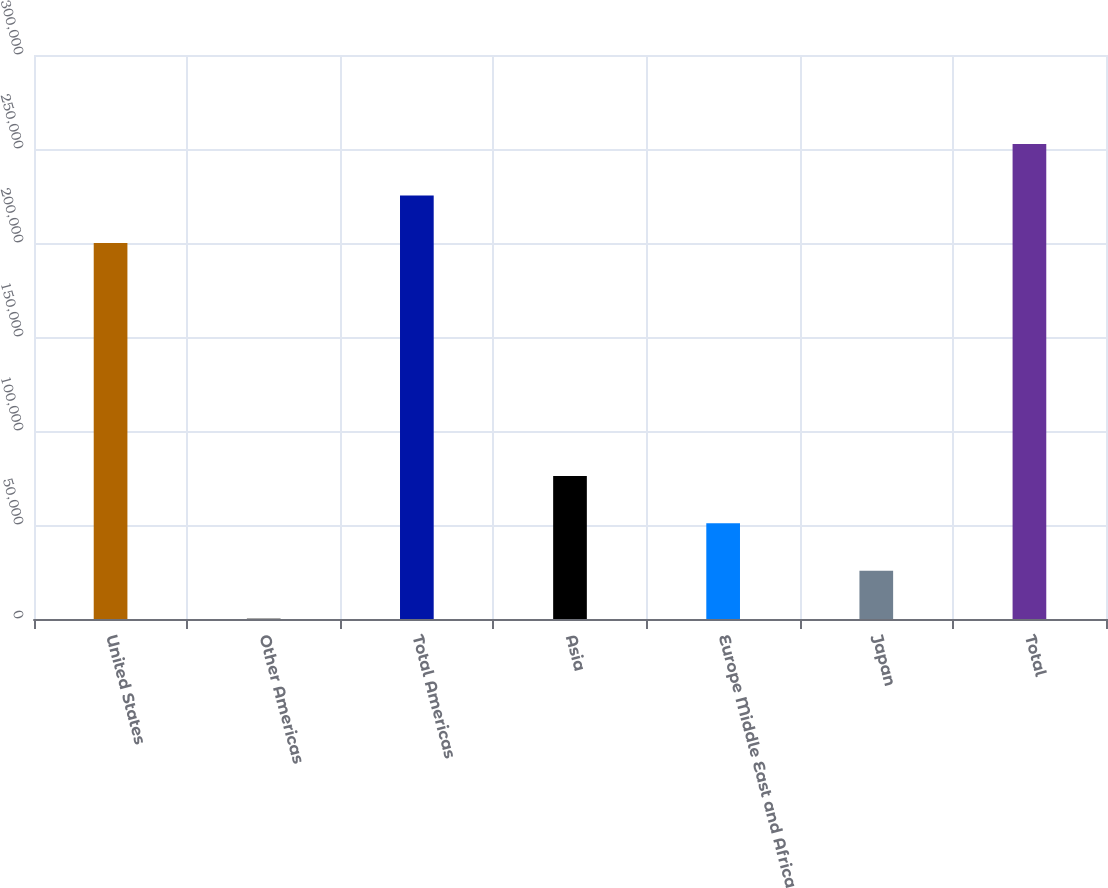Convert chart. <chart><loc_0><loc_0><loc_500><loc_500><bar_chart><fcel>United States<fcel>Other Americas<fcel>Total Americas<fcel>Asia<fcel>Europe Middle East and Africa<fcel>Japan<fcel>Total<nl><fcel>200025<fcel>475<fcel>225240<fcel>76121.5<fcel>50906<fcel>25690.5<fcel>252630<nl></chart> 